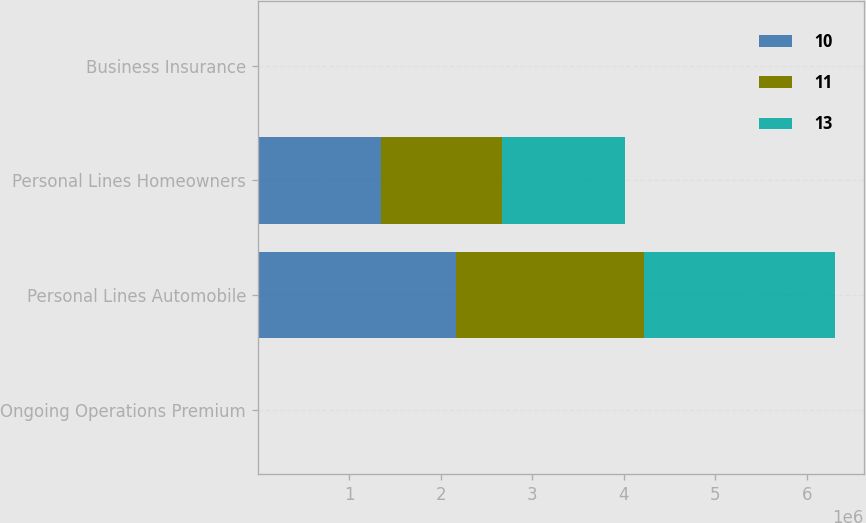<chart> <loc_0><loc_0><loc_500><loc_500><stacked_bar_chart><ecel><fcel>Ongoing Operations Premium<fcel>Personal Lines Automobile<fcel>Personal Lines Homeowners<fcel>Business Insurance<nl><fcel>10<fcel>2004<fcel>2.16692e+06<fcel>1.34857e+06<fcel>2<nl><fcel>11<fcel>2003<fcel>2.05882e+06<fcel>1.31963e+06<fcel>9<nl><fcel>13<fcel>2002<fcel>2.08121e+06<fcel>1.33991e+06<fcel>17<nl></chart> 